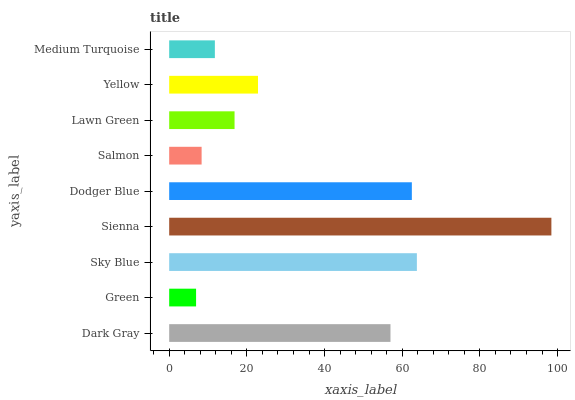Is Green the minimum?
Answer yes or no. Yes. Is Sienna the maximum?
Answer yes or no. Yes. Is Sky Blue the minimum?
Answer yes or no. No. Is Sky Blue the maximum?
Answer yes or no. No. Is Sky Blue greater than Green?
Answer yes or no. Yes. Is Green less than Sky Blue?
Answer yes or no. Yes. Is Green greater than Sky Blue?
Answer yes or no. No. Is Sky Blue less than Green?
Answer yes or no. No. Is Yellow the high median?
Answer yes or no. Yes. Is Yellow the low median?
Answer yes or no. Yes. Is Dark Gray the high median?
Answer yes or no. No. Is Dodger Blue the low median?
Answer yes or no. No. 